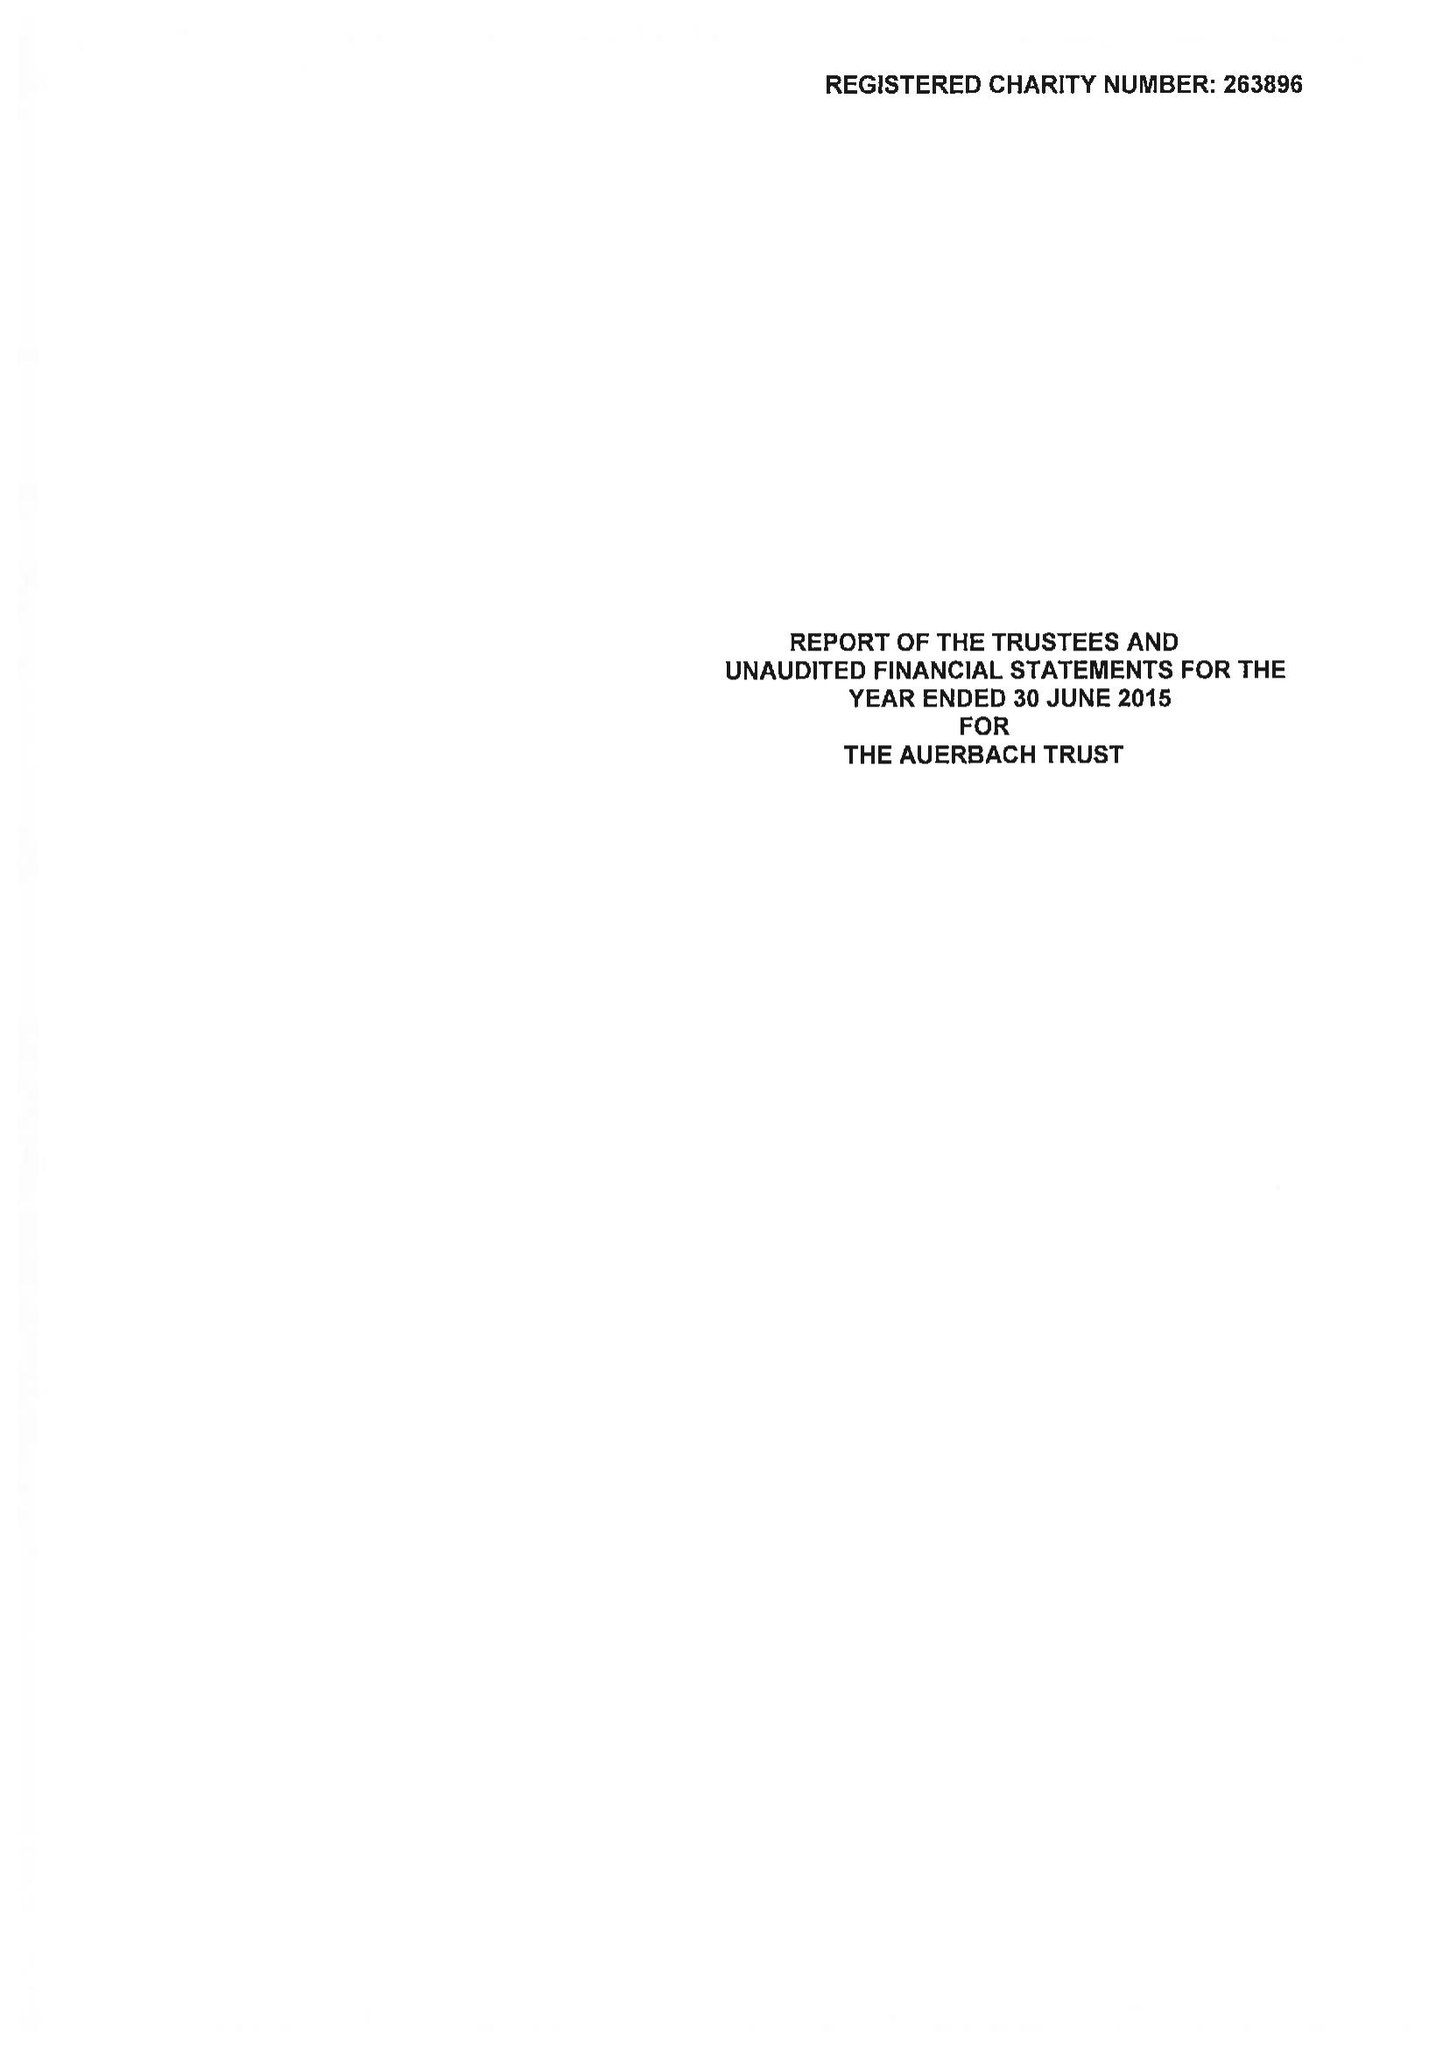What is the value for the income_annually_in_british_pounds?
Answer the question using a single word or phrase. 55421.00 